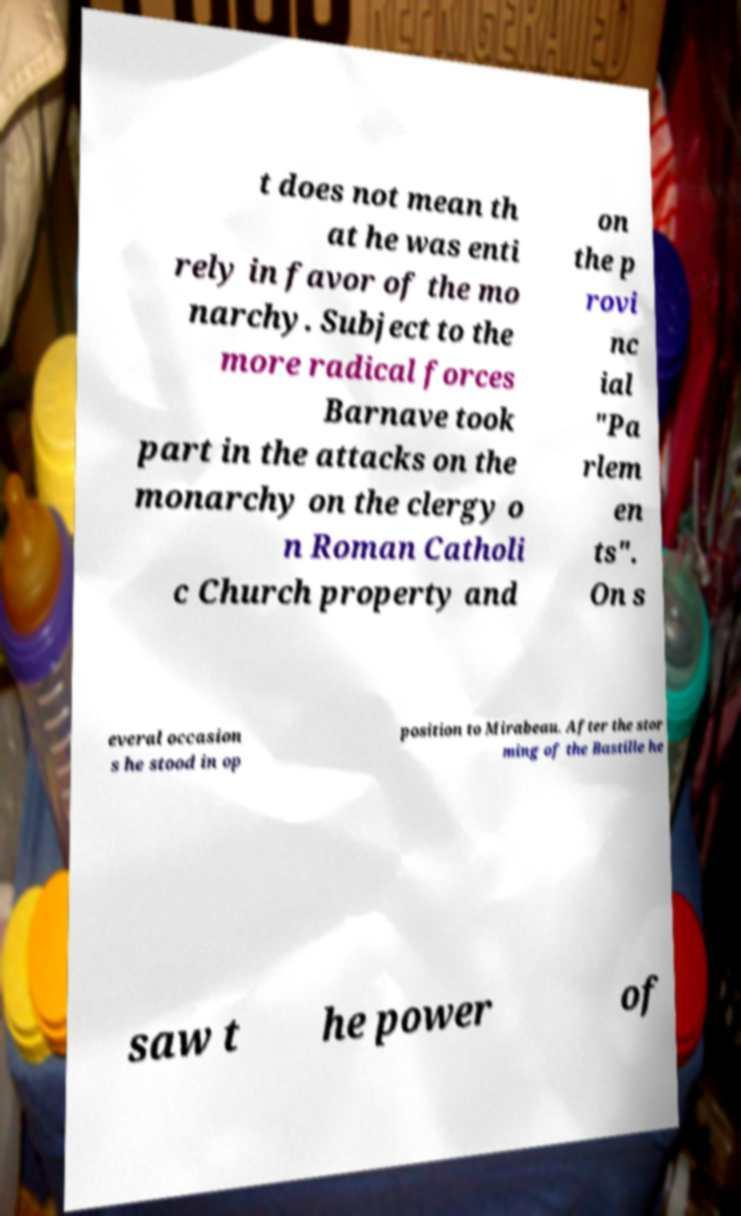Can you accurately transcribe the text from the provided image for me? t does not mean th at he was enti rely in favor of the mo narchy. Subject to the more radical forces Barnave took part in the attacks on the monarchy on the clergy o n Roman Catholi c Church property and on the p rovi nc ial "Pa rlem en ts". On s everal occasion s he stood in op position to Mirabeau. After the stor ming of the Bastille he saw t he power of 